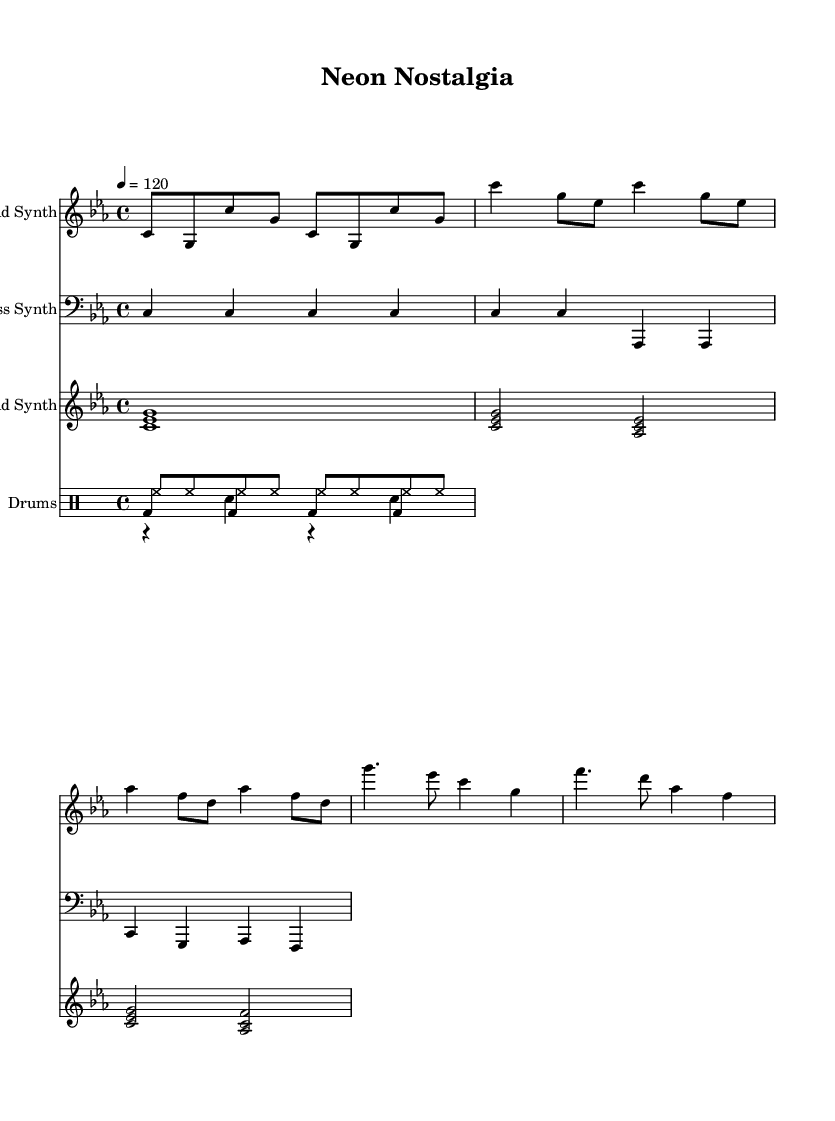What is the key signature of this music? The key signature is C minor, which has three flats: B flat, E flat, and A flat. This can be identified by looking at the key signature clefs, specifically noting the three flat symbols placed on the staff.
Answer: C minor What is the time signature of the piece? The time signature is 4/4, which is indicated at the beginning of the sheet music. It tells us that there are four beats in each measure and that a quarter note receives one beat.
Answer: 4/4 What is the tempo marking of this music? The tempo marking is 120 beats per minute, stated at the beginning of the score as "4 = 120". This means that the quarter note is to be played at a speed of 120 beats per minute.
Answer: 120 How many measures are in the verse section? The verse section consists of two measures. This observation can be made by counting the measures notated in the lead synth part, specifically looking at the section labeled "Verse" in the score.
Answer: 2 What type of synthesizer plays the pad chords? The pad chords are played by the Pad Synth, which can be identified by observing the staff labeled "Pad Synth" and the notation used which consists of chord symbols.
Answer: Pad Synth How many drum voices are used in the drum staff? There are three drum voices in the drum staff. This can be determined by looking at the different voices labeled "Kick Drum", "Snare Drum", and "Hi-Hat" in the drum staff section of the score.
Answer: 3 What are the main chord types used in the chorus? The main chord types used in the chorus are major chords and minor chords. This is deduced by looking at the notes in the pad synth part, where major and minor intervals are employed, typical for synthwave music.
Answer: Major and minor chords 